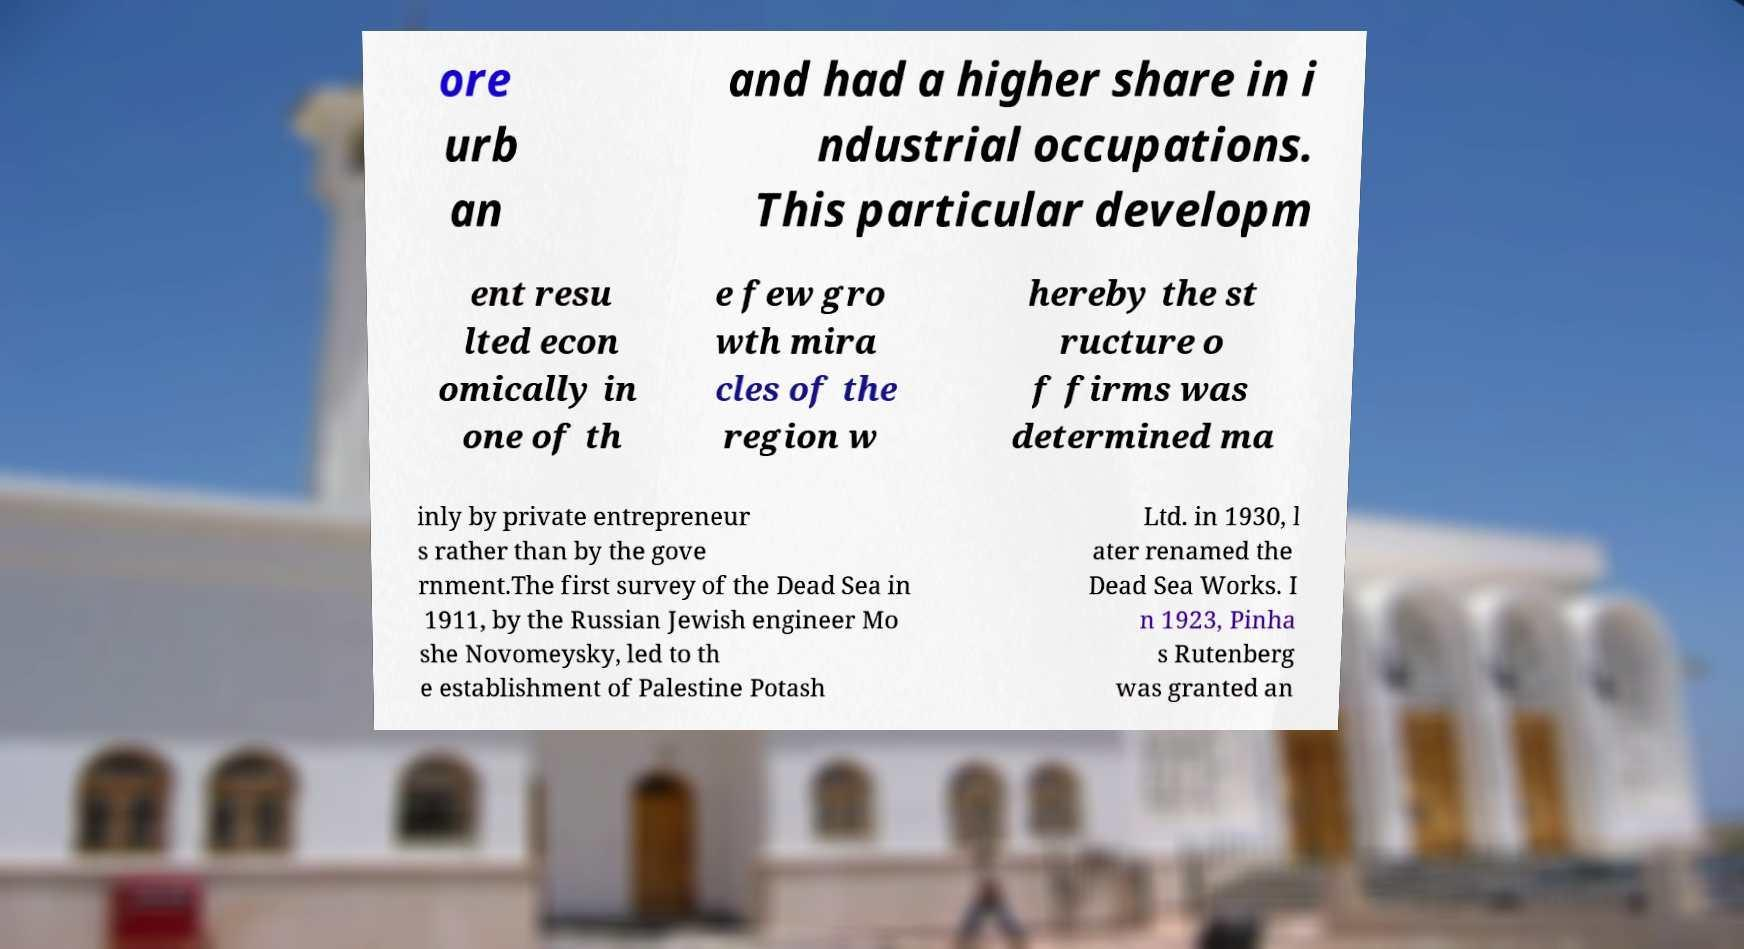Please identify and transcribe the text found in this image. ore urb an and had a higher share in i ndustrial occupations. This particular developm ent resu lted econ omically in one of th e few gro wth mira cles of the region w hereby the st ructure o f firms was determined ma inly by private entrepreneur s rather than by the gove rnment.The first survey of the Dead Sea in 1911, by the Russian Jewish engineer Mo she Novomeysky, led to th e establishment of Palestine Potash Ltd. in 1930, l ater renamed the Dead Sea Works. I n 1923, Pinha s Rutenberg was granted an 